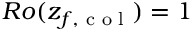Convert formula to latex. <formula><loc_0><loc_0><loc_500><loc_500>R o ( z _ { f , c o l } ) = 1</formula> 